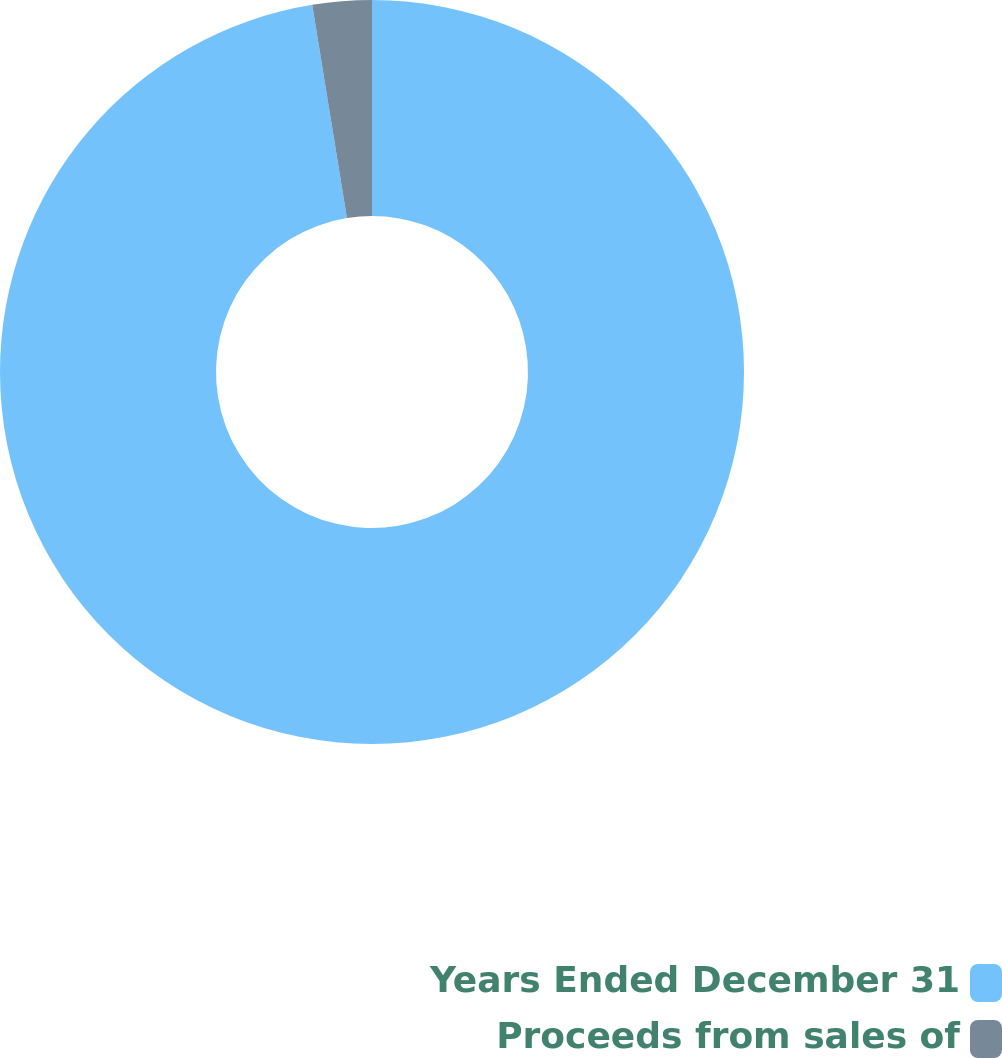Convert chart to OTSL. <chart><loc_0><loc_0><loc_500><loc_500><pie_chart><fcel>Years Ended December 31<fcel>Proceeds from sales of<nl><fcel>97.43%<fcel>2.57%<nl></chart> 